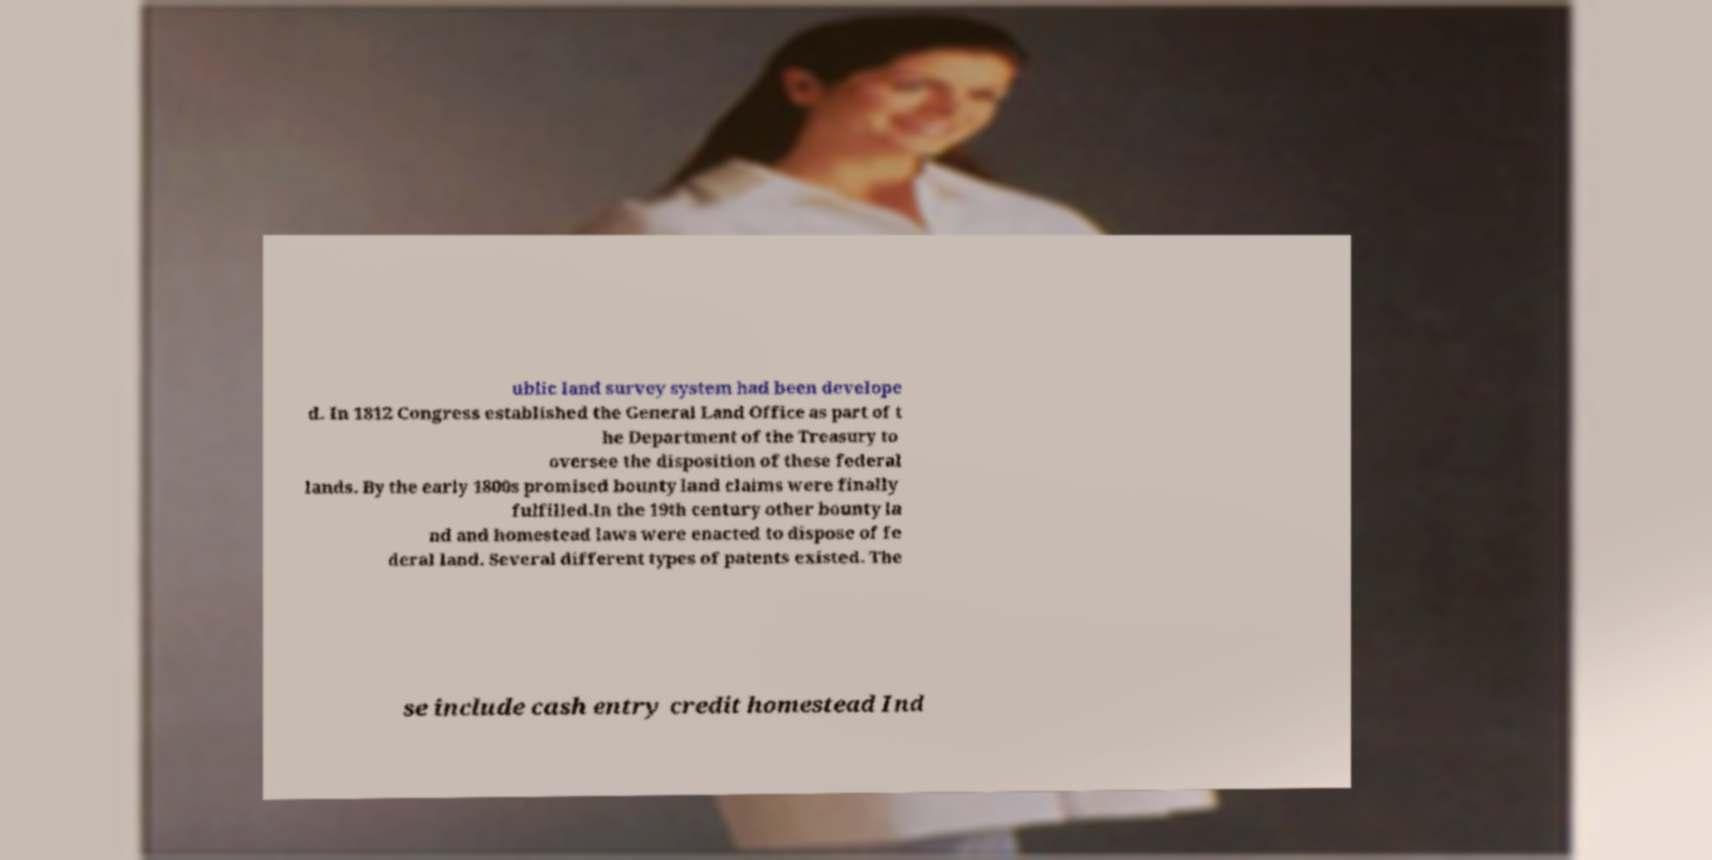There's text embedded in this image that I need extracted. Can you transcribe it verbatim? ublic land survey system had been develope d. In 1812 Congress established the General Land Office as part of t he Department of the Treasury to oversee the disposition of these federal lands. By the early 1800s promised bounty land claims were finally fulfilled.In the 19th century other bounty la nd and homestead laws were enacted to dispose of fe deral land. Several different types of patents existed. The se include cash entry credit homestead Ind 